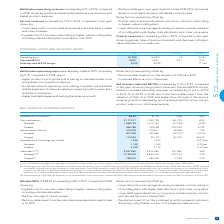According to Bce's financial document, What was excluded in the Q1 2018 blended ABPU? the unfavourable retroactive impact of the CRTC decision on wireless domestic wholesale roaming rates of $14 million.. The document states: ") Our Q1 2018 blended ABPU was adjusted to exclude the unfavourable retroactive impact of the CRTC decision on wireless domestic wholesale roaming rat..." Also, How many subscribers were removed when the postpaid wireless subscriber base was adjusted at the beginning of Q4 2018? According to the financial document, 20,000. The relevant text states: "d our postpaid wireless subscriber base to remove 20,000 subscribers that we divested to Xplornet as a result of BCE’s acquisition of MTS in 2017...." Also, What is the blended ABPU ($/month) in 2019? According to the financial document, 68.32. The relevant text states: "Blended ABPU ($/month) (1) 68.32 67.76 0.56 0.8%..." Also, can you calculate: What is the total amount of gross activations for prepaid in 2019 and 2018? Based on the calculation: 548,788+339,028, the result is 887816. This is based on the information: "Prepaid 548,788 339,028 209,760 61.9% Prepaid 548,788 339,028 209,760 61.9%..." The key data points involved are: 339,028, 548,788. Also, can you calculate: What is the percentage of postpaid in the net activations in 2019? Based on the calculation: 401,955/515,409, the result is 77.99 (percentage). This is based on the information: "Net activations (losses) 515,409 479,811 35,598 7.4% Postpaid 401,955 447,682 (45,727) (10.2%)..." The key data points involved are: 401,955, 515,409. Also, can you calculate: What is the Blended ABPU rate per year for 2019? Based on the calculation: 68.32*12, the result is 819.84. This is based on the information: "Prepaid 113,454 32,129 81,325 253.1% Blended ABPU ($/month) (1) 68.32 67.76 0.56 0.8%..." The key data points involved are: 12, 68.32. 